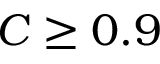Convert formula to latex. <formula><loc_0><loc_0><loc_500><loc_500>C \geq 0 . 9</formula> 